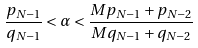Convert formula to latex. <formula><loc_0><loc_0><loc_500><loc_500>\frac { p _ { N - 1 } } { q _ { N - 1 } } < \alpha < \frac { M p _ { N - 1 } + p _ { N - 2 } } { M q _ { N - 1 } + q _ { N - 2 } }</formula> 